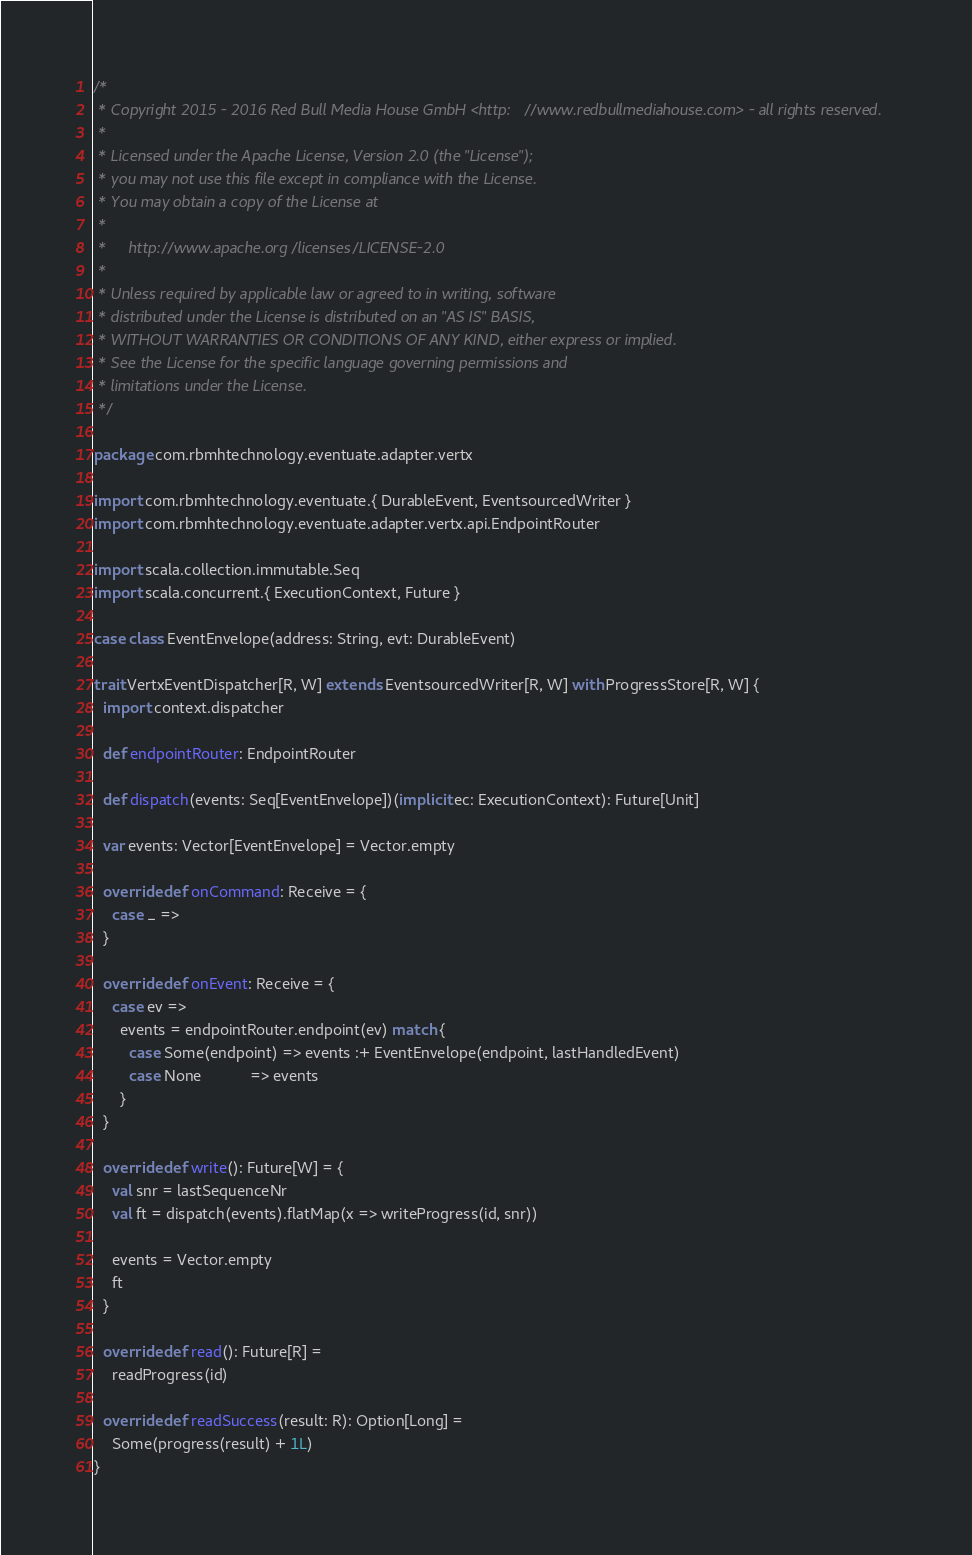<code> <loc_0><loc_0><loc_500><loc_500><_Scala_>/*
 * Copyright 2015 - 2016 Red Bull Media House GmbH <http://www.redbullmediahouse.com> - all rights reserved.
 *
 * Licensed under the Apache License, Version 2.0 (the "License");
 * you may not use this file except in compliance with the License.
 * You may obtain a copy of the License at
 *
 *     http://www.apache.org/licenses/LICENSE-2.0
 *
 * Unless required by applicable law or agreed to in writing, software
 * distributed under the License is distributed on an "AS IS" BASIS,
 * WITHOUT WARRANTIES OR CONDITIONS OF ANY KIND, either express or implied.
 * See the License for the specific language governing permissions and
 * limitations under the License.
 */

package com.rbmhtechnology.eventuate.adapter.vertx

import com.rbmhtechnology.eventuate.{ DurableEvent, EventsourcedWriter }
import com.rbmhtechnology.eventuate.adapter.vertx.api.EndpointRouter

import scala.collection.immutable.Seq
import scala.concurrent.{ ExecutionContext, Future }

case class EventEnvelope(address: String, evt: DurableEvent)

trait VertxEventDispatcher[R, W] extends EventsourcedWriter[R, W] with ProgressStore[R, W] {
  import context.dispatcher

  def endpointRouter: EndpointRouter

  def dispatch(events: Seq[EventEnvelope])(implicit ec: ExecutionContext): Future[Unit]

  var events: Vector[EventEnvelope] = Vector.empty

  override def onCommand: Receive = {
    case _ =>
  }

  override def onEvent: Receive = {
    case ev =>
      events = endpointRouter.endpoint(ev) match {
        case Some(endpoint) => events :+ EventEnvelope(endpoint, lastHandledEvent)
        case None           => events
      }
  }

  override def write(): Future[W] = {
    val snr = lastSequenceNr
    val ft = dispatch(events).flatMap(x => writeProgress(id, snr))

    events = Vector.empty
    ft
  }

  override def read(): Future[R] =
    readProgress(id)

  override def readSuccess(result: R): Option[Long] =
    Some(progress(result) + 1L)
}
</code> 